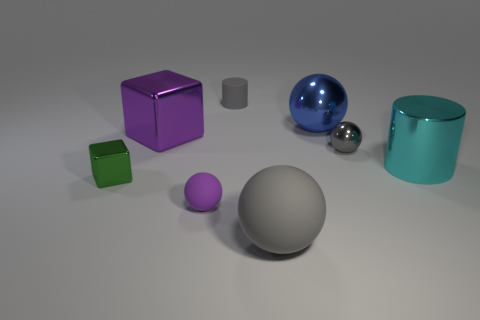Add 1 large blue things. How many objects exist? 9 Subtract all cylinders. How many objects are left? 6 Add 8 big purple things. How many big purple things exist? 9 Subtract 0 gray blocks. How many objects are left? 8 Subtract all purple matte spheres. Subtract all small cylinders. How many objects are left? 6 Add 1 large cyan shiny cylinders. How many large cyan shiny cylinders are left? 2 